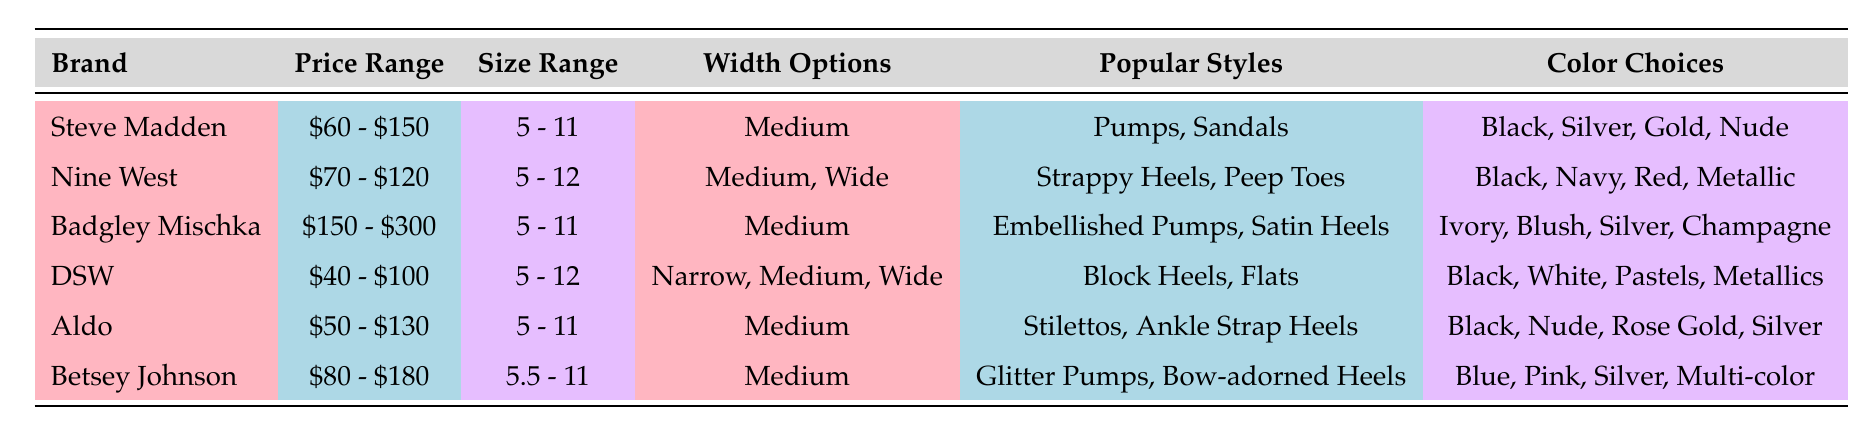What is the price range for Badgley Mischka shoes? The table shows that Badgley Mischka has a price range listed as $150 - $300.
Answer: $150 - $300 Which brands offer width options in Wide? From the table, Nine West is the only brand listed that offers width options in Wide.
Answer: Nine West What are the color choices for Steve Madden shoes? The table indicates that the color choices for Steve Madden shoes are Black, Silver, Gold, and Nude.
Answer: Black, Silver, Gold, Nude How many brands offer shoes in the size range 5 - 11? The brands that offer shoes in the size range of 5 - 11 are Steve Madden, Badgley Mischka, Aldo, and Betsey Johnson, totaling 4 brands.
Answer: 4 Are there any brands that have a price range under $100? The table shows two brands, DSW with a range of $40 - $100 and Steve Madden with a range of $60 - $150. Since DSW is priced under $100, the answer is yes.
Answer: Yes Which brand has the highest maximum price? The maximum price listed in the table is $300 for Badgley Mischka, making it the brand with the highest maximum price.
Answer: Badgley Mischka What is the average price range of the brands listed? The price ranges are: $60 - $150, $70 - $120, $150 - $300, $40 - $100, $50 - $130, $80 - $180. Converting these ranges to midpoints gives: $105, $95, $225, $70, $90, and $130 respectively. The sum is $105 + $95 + $225 + $70 + $90 + $130 = $915, and there are 6 brands, so the average is approximately $915 / 6 = $152.5. Thus, the average price is approximately $152.5.
Answer: $152.5 What popular style is offered by Aldo? The popular styles offered by Aldo, as stated in the table, are Stilettos and Ankle Strap Heels.
Answer: Stilettos, Ankle Strap Heels Which brand has the widest size range? The brand with the widest size range is DSW, offering sizes from 5 to 12, which is a total range of 8 sizes.
Answer: DSW 